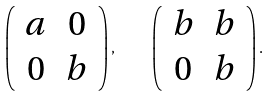Convert formula to latex. <formula><loc_0><loc_0><loc_500><loc_500>\left ( \begin{array} { c c } a & 0 \\ 0 & b \end{array} \right ) , \quad \left ( \begin{array} { c c } b & b \\ 0 & b \end{array} \right ) .</formula> 